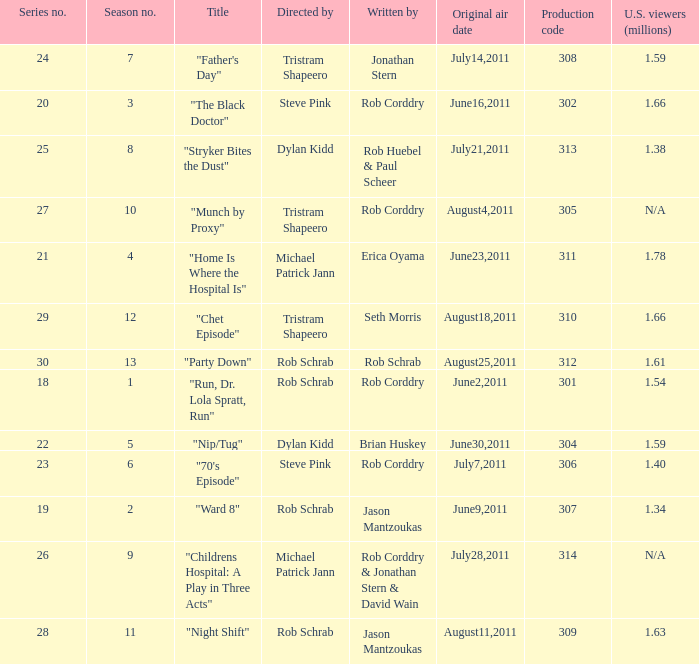The episode entitled "ward 8" was what number in the series? 19.0. 